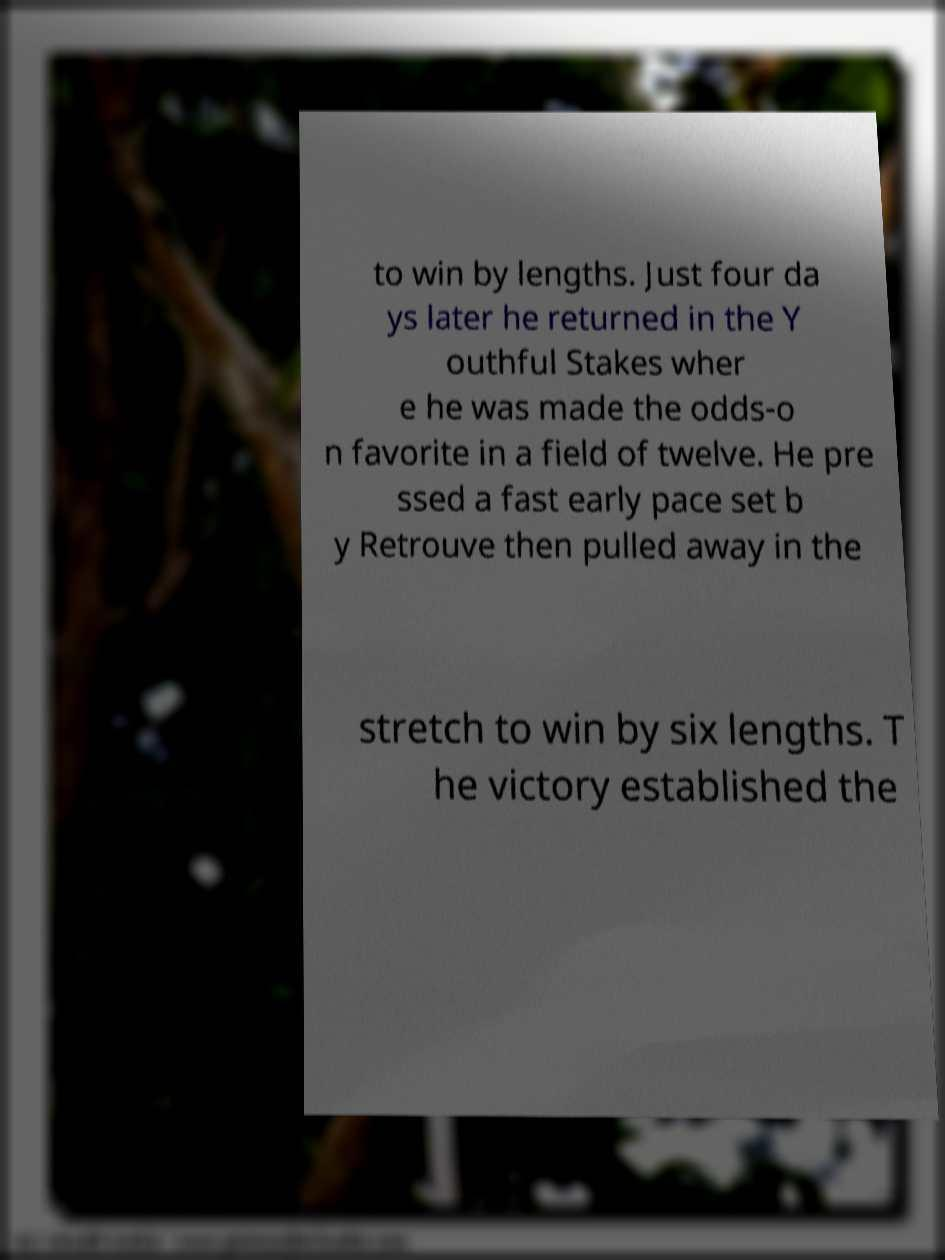Could you assist in decoding the text presented in this image and type it out clearly? to win by lengths. Just four da ys later he returned in the Y outhful Stakes wher e he was made the odds-o n favorite in a field of twelve. He pre ssed a fast early pace set b y Retrouve then pulled away in the stretch to win by six lengths. T he victory established the 